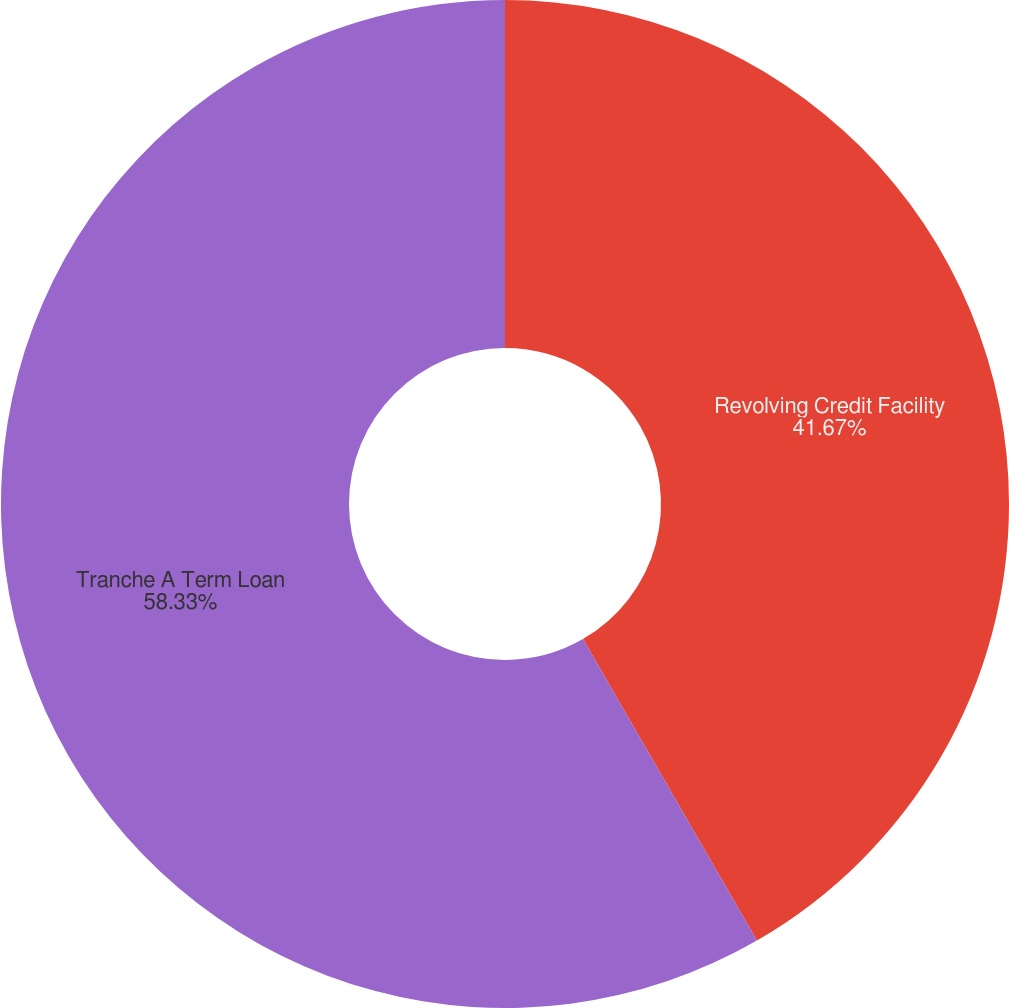Convert chart. <chart><loc_0><loc_0><loc_500><loc_500><pie_chart><fcel>Revolving Credit Facility<fcel>Tranche A Term Loan<nl><fcel>41.67%<fcel>58.33%<nl></chart> 